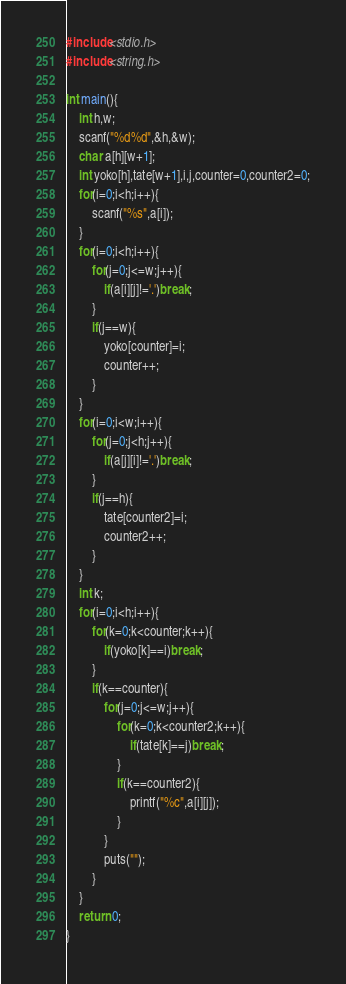<code> <loc_0><loc_0><loc_500><loc_500><_C_>#include<stdio.h>
#include<string.h>

int main(){
	int h,w;
	scanf("%d%d",&h,&w);
	char a[h][w+1];
	int yoko[h],tate[w+1],i,j,counter=0,counter2=0;
	for(i=0;i<h;i++){
		scanf("%s",a[i]);
	}
	for(i=0;i<h;i++){
		for(j=0;j<=w;j++){
			if(a[i][j]!='.')break;	
		}
		if(j==w){
			yoko[counter]=i;
			counter++;
		}
	}
	for(i=0;i<w;i++){
		for(j=0;j<h;j++){
			if(a[j][i]!='.')break;	
		}
		if(j==h){
			tate[counter2]=i;
			counter2++;
		}
	}
	int k;
	for(i=0;i<h;i++){
		for(k=0;k<counter;k++){
			if(yoko[k]==i)break;
		}
		if(k==counter){
			for(j=0;j<=w;j++){
				for(k=0;k<counter2;k++){
					if(tate[k]==j)break;
				}
				if(k==counter2){
					printf("%c",a[i][j]);
				}
			}
			puts("");
		}
	}
	return 0;
}</code> 